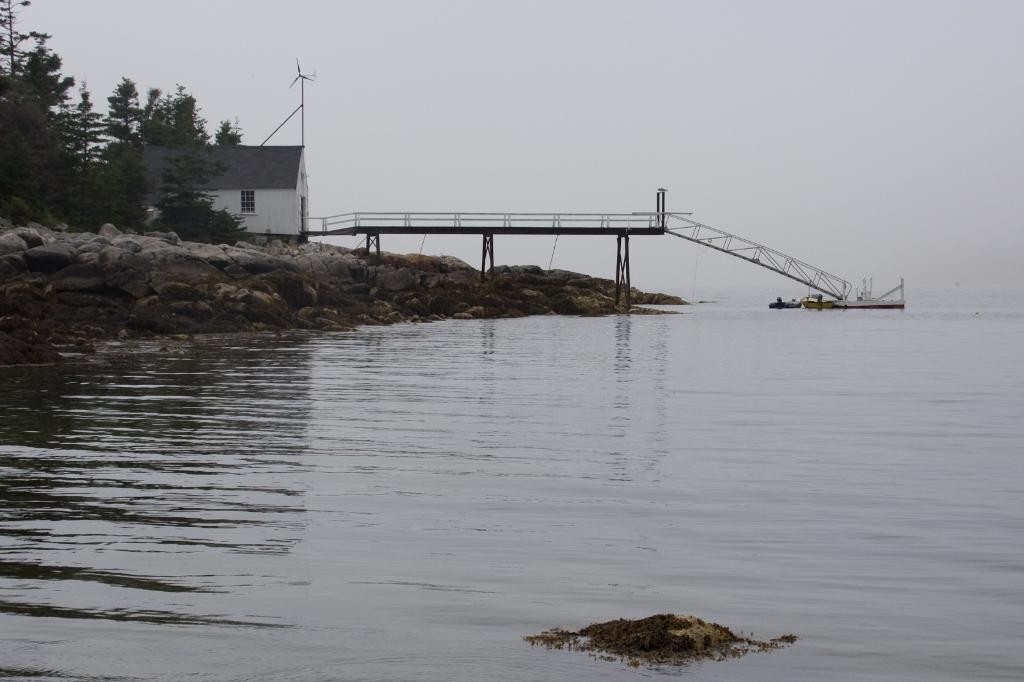Can you describe this image briefly? At the bottom of the image there is a river. On the left we can see a shed and trees. In the center there is a bridge. In the background we can see sky. 